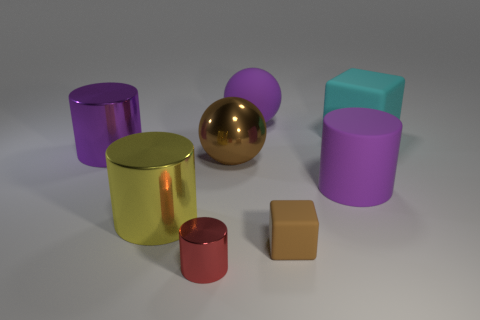Are there any other things that are made of the same material as the small brown object?
Your response must be concise. Yes. How many large yellow shiny cubes are there?
Provide a succinct answer. 0. Is the shape of the tiny shiny object the same as the object that is to the right of the big rubber cylinder?
Offer a very short reply. No. How many things are matte cylinders or metal objects that are on the right side of the red cylinder?
Your response must be concise. 2. What is the material of the red object that is the same shape as the yellow metallic object?
Ensure brevity in your answer.  Metal. Does the shiny thing to the right of the tiny red metal cylinder have the same shape as the cyan rubber thing?
Your response must be concise. No. Is the number of small brown matte objects that are in front of the small shiny cylinder less than the number of metallic cylinders that are right of the big block?
Give a very brief answer. No. How many other things are the same shape as the big yellow thing?
Provide a short and direct response. 3. There is a purple rubber object that is behind the cylinder that is behind the large metal thing to the right of the red metal object; how big is it?
Keep it short and to the point. Large. How many red objects are either big objects or tiny cylinders?
Your answer should be compact. 1. 